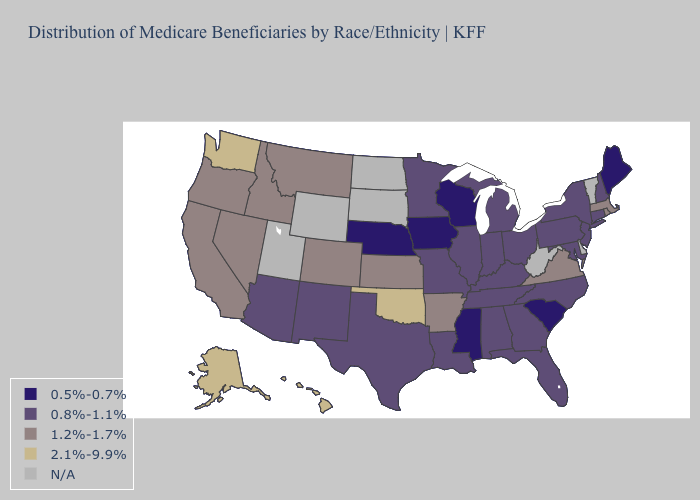What is the value of Kentucky?
Give a very brief answer. 0.8%-1.1%. Among the states that border Wyoming , does Colorado have the highest value?
Give a very brief answer. Yes. Does Maine have the lowest value in the USA?
Give a very brief answer. Yes. What is the lowest value in the Northeast?
Answer briefly. 0.5%-0.7%. What is the value of Washington?
Be succinct. 2.1%-9.9%. What is the value of Alabama?
Quick response, please. 0.8%-1.1%. What is the lowest value in the West?
Answer briefly. 0.8%-1.1%. Among the states that border Arkansas , which have the lowest value?
Answer briefly. Mississippi. Which states have the lowest value in the USA?
Short answer required. Iowa, Maine, Mississippi, Nebraska, South Carolina, Wisconsin. Which states have the lowest value in the USA?
Keep it brief. Iowa, Maine, Mississippi, Nebraska, South Carolina, Wisconsin. What is the lowest value in the USA?
Concise answer only. 0.5%-0.7%. Which states have the lowest value in the USA?
Answer briefly. Iowa, Maine, Mississippi, Nebraska, South Carolina, Wisconsin. Name the states that have a value in the range N/A?
Concise answer only. Delaware, North Dakota, South Dakota, Utah, Vermont, West Virginia, Wyoming. Which states have the lowest value in the South?
Give a very brief answer. Mississippi, South Carolina. 